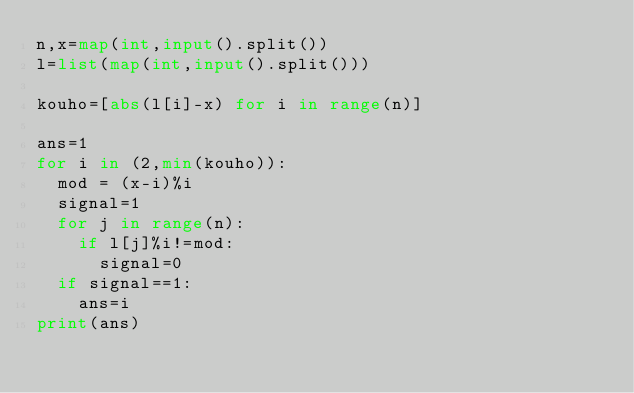Convert code to text. <code><loc_0><loc_0><loc_500><loc_500><_Python_>n,x=map(int,input().split())
l=list(map(int,input().split()))

kouho=[abs(l[i]-x) for i in range(n)]

ans=1
for i in (2,min(kouho)):
  mod = (x-i)%i
  signal=1
  for j in range(n):
    if l[j]%i!=mod:
      signal=0
  if signal==1:
    ans=i
print(ans)</code> 